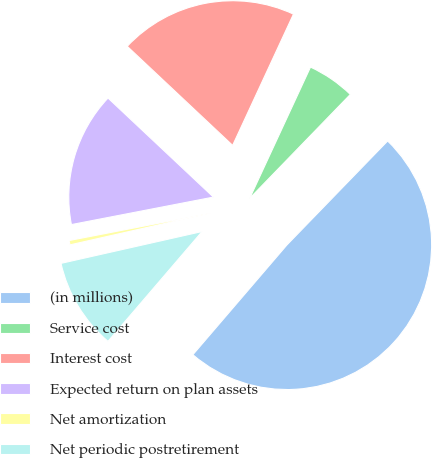Convert chart. <chart><loc_0><loc_0><loc_500><loc_500><pie_chart><fcel>(in millions)<fcel>Service cost<fcel>Interest cost<fcel>Expected return on plan assets<fcel>Net amortization<fcel>Net periodic postretirement<nl><fcel>49.03%<fcel>5.34%<fcel>19.9%<fcel>15.05%<fcel>0.49%<fcel>10.19%<nl></chart> 